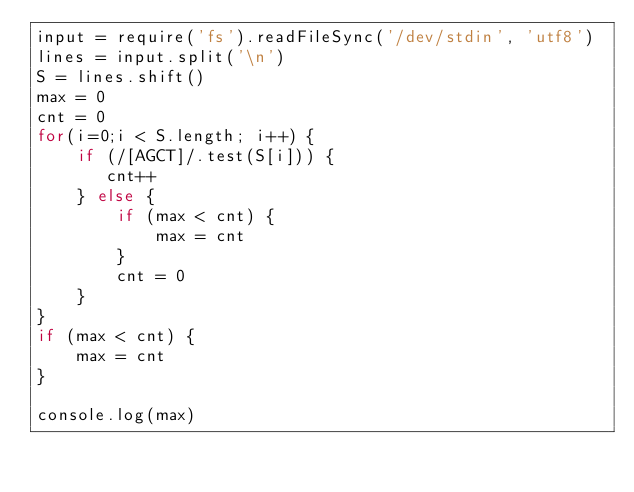<code> <loc_0><loc_0><loc_500><loc_500><_JavaScript_>input = require('fs').readFileSync('/dev/stdin', 'utf8')
lines = input.split('\n')
S = lines.shift()
max = 0
cnt = 0
for(i=0;i < S.length; i++) {
    if (/[AGCT]/.test(S[i])) {
       cnt++ 
    } else {
        if (max < cnt) {
            max = cnt
        }
        cnt = 0
    }
}
if (max < cnt) {
    max = cnt
}

console.log(max)</code> 